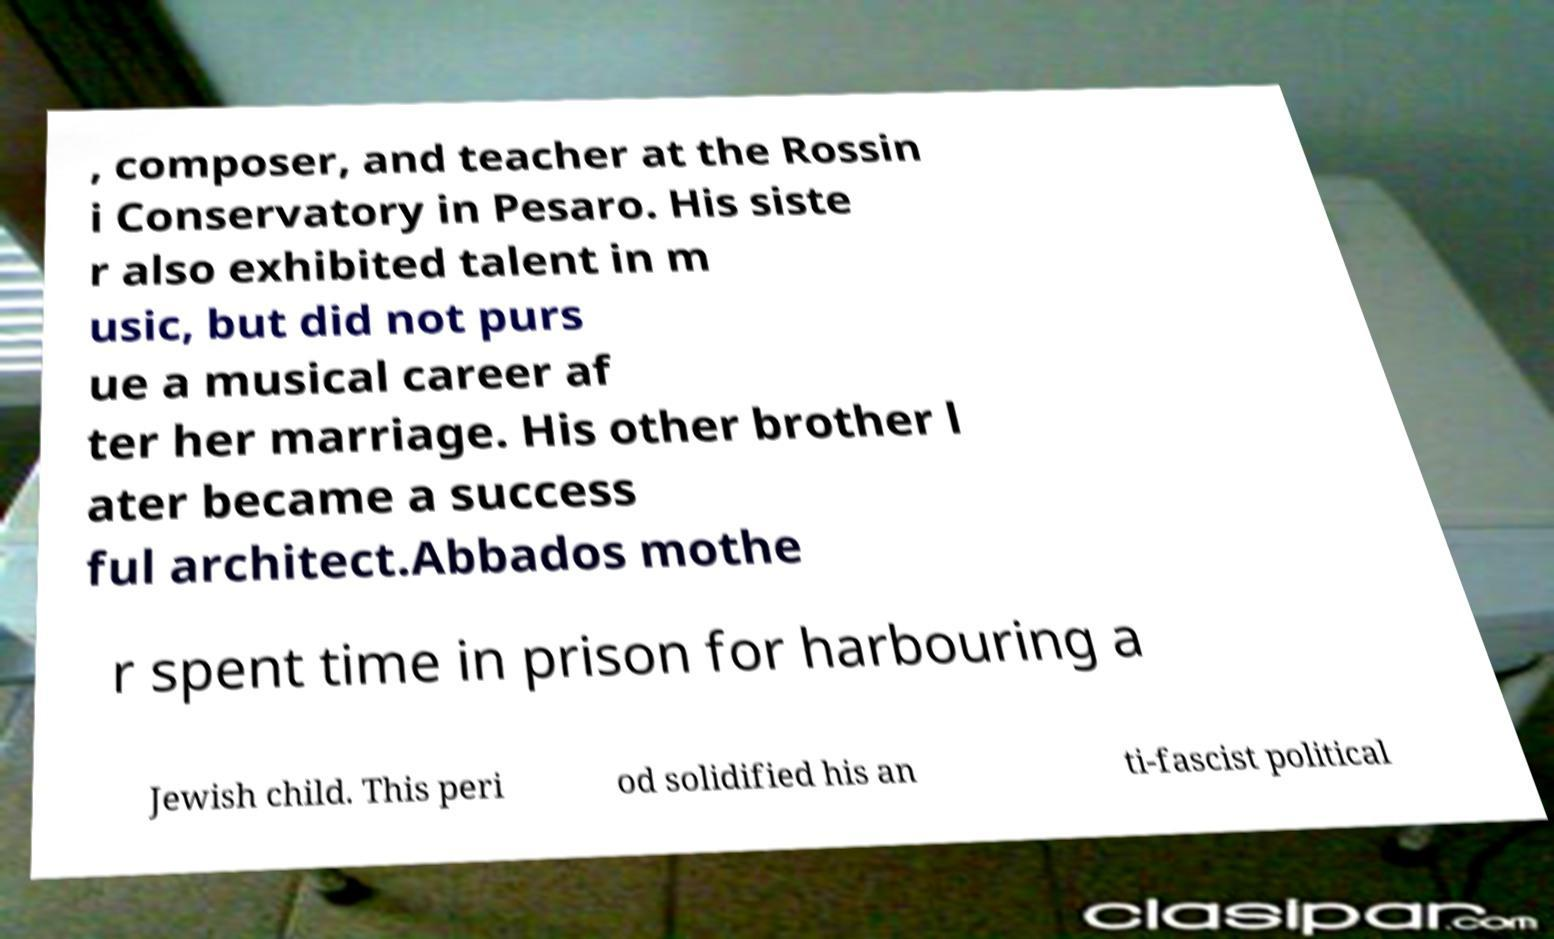What messages or text are displayed in this image? I need them in a readable, typed format. , composer, and teacher at the Rossin i Conservatory in Pesaro. His siste r also exhibited talent in m usic, but did not purs ue a musical career af ter her marriage. His other brother l ater became a success ful architect.Abbados mothe r spent time in prison for harbouring a Jewish child. This peri od solidified his an ti-fascist political 